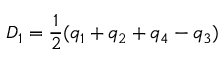Convert formula to latex. <formula><loc_0><loc_0><loc_500><loc_500>D _ { 1 } = \frac { 1 } { 2 } ( q _ { 1 } + q _ { 2 } + q _ { 4 } - q _ { 3 } )</formula> 